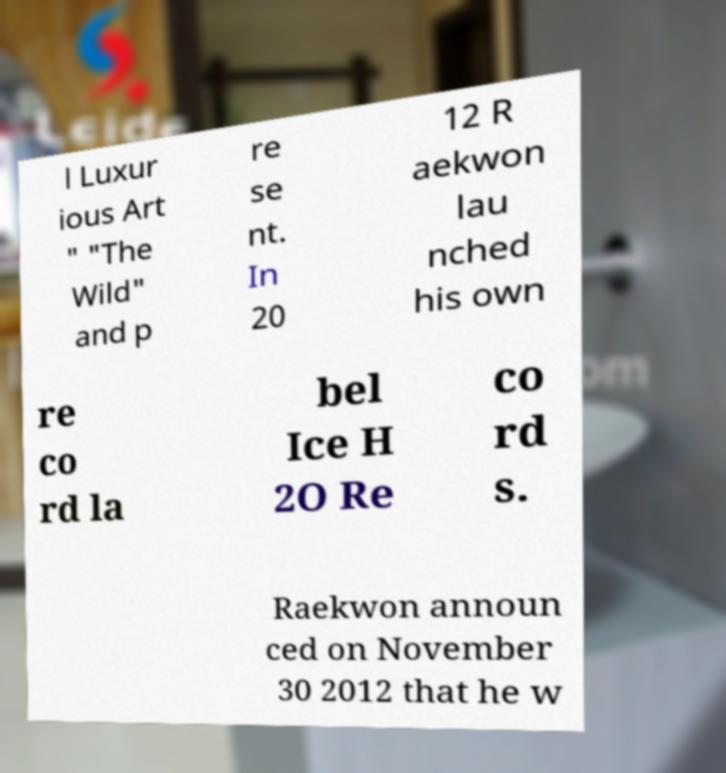Please read and relay the text visible in this image. What does it say? l Luxur ious Art " "The Wild" and p re se nt. In 20 12 R aekwon lau nched his own re co rd la bel Ice H 2O Re co rd s. Raekwon announ ced on November 30 2012 that he w 